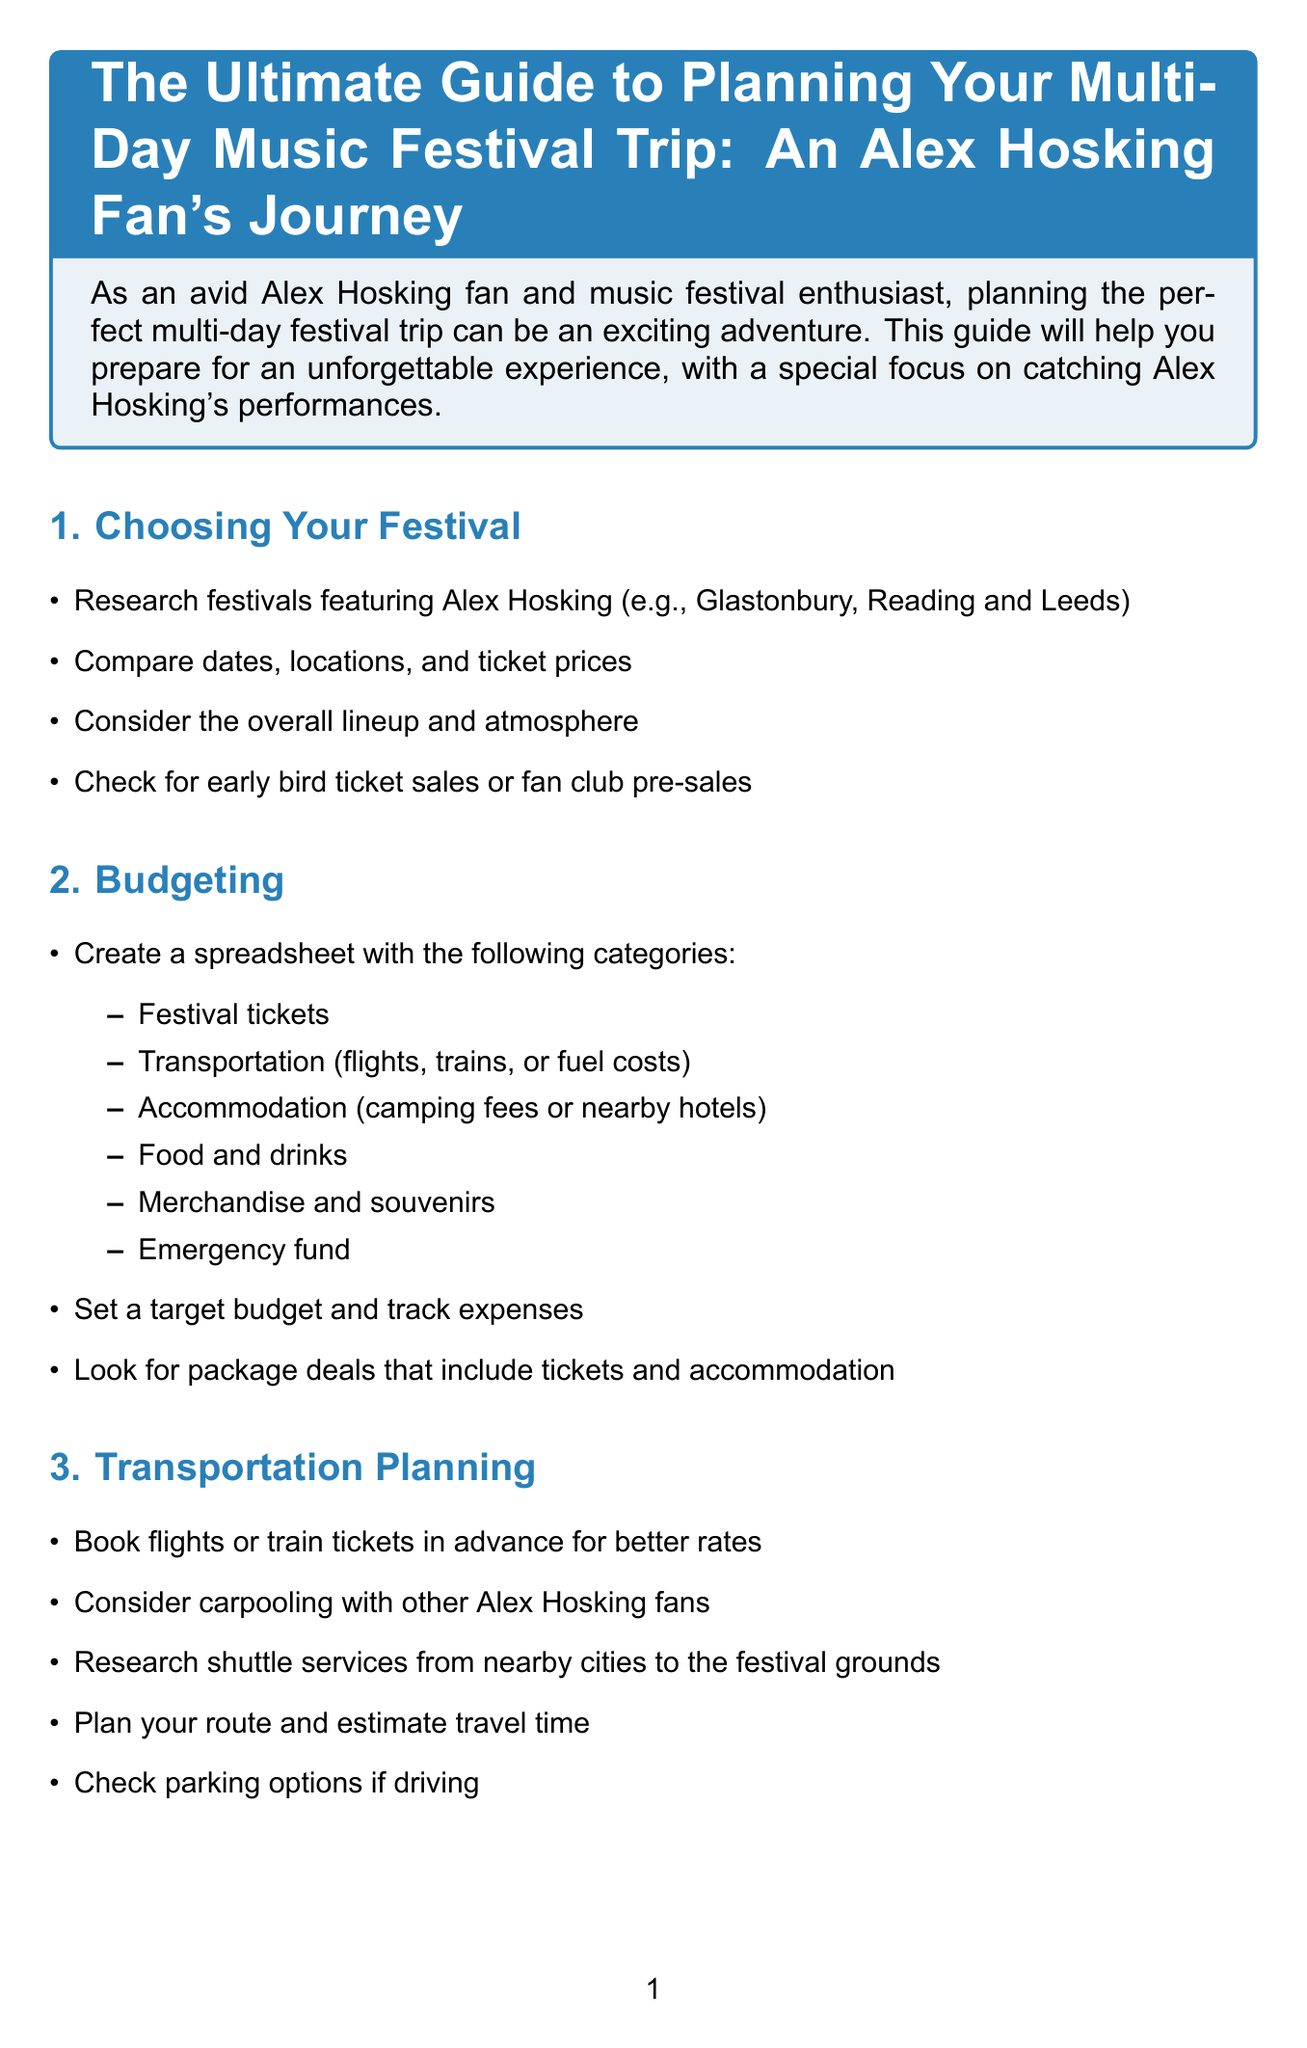What are the festivals mentioned for Alex Hosking? The document lists Glastonbury and Reading and Leeds as festivals featuring Alex Hosking.
Answer: Glastonbury, Reading and Leeds What is the estimated cost for Food and Drinks? The budget template shows the estimated cost specifically for Food and Drinks.
Answer: 200 What should you pack for Camping Gear? The document provides a list of items to pack for camping, which includes essential camping gear.
Answer: Tent and sleeping bag What should you consider when booking accommodation? The guide suggests considering whether to camp on-site or stay in nearby hotels when planning accommodation.
Answer: Camping on-site or hotels How many categories are in the budgeting section? The document specifies a total of six categories in the budgeting section, which are listed clearly.
Answer: 6 What item is recommended for health and safety preparations? The guide mentions bringing necessary medications as an important health and safety preparation.
Answer: Necessary medications What should you do after the festival? The final section of the document advises allowing for a rest day after the festival before traveling home.
Answer: Allow for a rest day What gear is specified for Alex Hosking fans? The packing list includes specific gear for fans of Alex Hosking, highlighting items fans should take to the festival.
Answer: Alex Hosking t-shirts or merchandise Which festival encourages joining social media fan groups? The document encourages joining Alex Hosking fan groups on social media to enhance the experience at the festival.
Answer: Alex Hosking What is recommended for daily meals budget? The document advises budgeting for daily meals as part of the food and drink strategy.
Answer: Budget for daily meals 